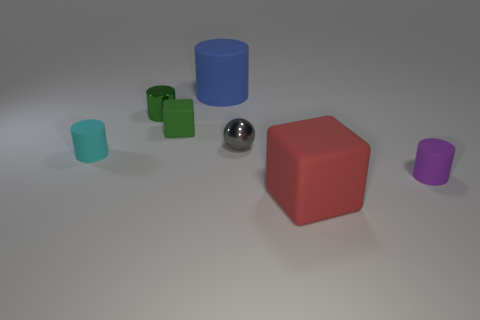There is a tiny purple object that is the same shape as the cyan rubber thing; what is its material?
Offer a very short reply. Rubber. Is there anything else that is the same size as the gray thing?
Keep it short and to the point. Yes. What shape is the big rubber object that is to the left of the big red cube?
Your response must be concise. Cylinder. What number of blue objects are the same shape as the green rubber object?
Give a very brief answer. 0. Is the number of small metallic spheres behind the big blue thing the same as the number of tiny gray things behind the purple object?
Your response must be concise. No. Are there any small green cubes that have the same material as the ball?
Keep it short and to the point. No. Does the large cylinder have the same material as the red thing?
Make the answer very short. Yes. How many blue things are spheres or large things?
Your response must be concise. 1. Are there more small spheres that are behind the green cylinder than tiny cubes?
Give a very brief answer. No. Are there any tiny objects of the same color as the tiny metal ball?
Provide a short and direct response. No. 